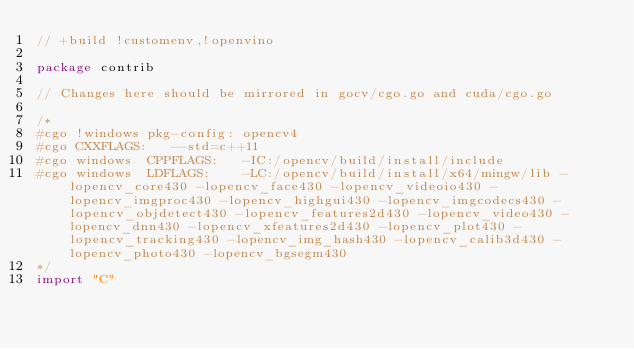Convert code to text. <code><loc_0><loc_0><loc_500><loc_500><_Go_>// +build !customenv,!openvino

package contrib

// Changes here should be mirrored in gocv/cgo.go and cuda/cgo.go

/*
#cgo !windows pkg-config: opencv4
#cgo CXXFLAGS:   --std=c++11
#cgo windows  CPPFLAGS:   -IC:/opencv/build/install/include
#cgo windows  LDFLAGS:    -LC:/opencv/build/install/x64/mingw/lib -lopencv_core430 -lopencv_face430 -lopencv_videoio430 -lopencv_imgproc430 -lopencv_highgui430 -lopencv_imgcodecs430 -lopencv_objdetect430 -lopencv_features2d430 -lopencv_video430 -lopencv_dnn430 -lopencv_xfeatures2d430 -lopencv_plot430 -lopencv_tracking430 -lopencv_img_hash430 -lopencv_calib3d430 -lopencv_photo430 -lopencv_bgsegm430
*/
import "C"
</code> 